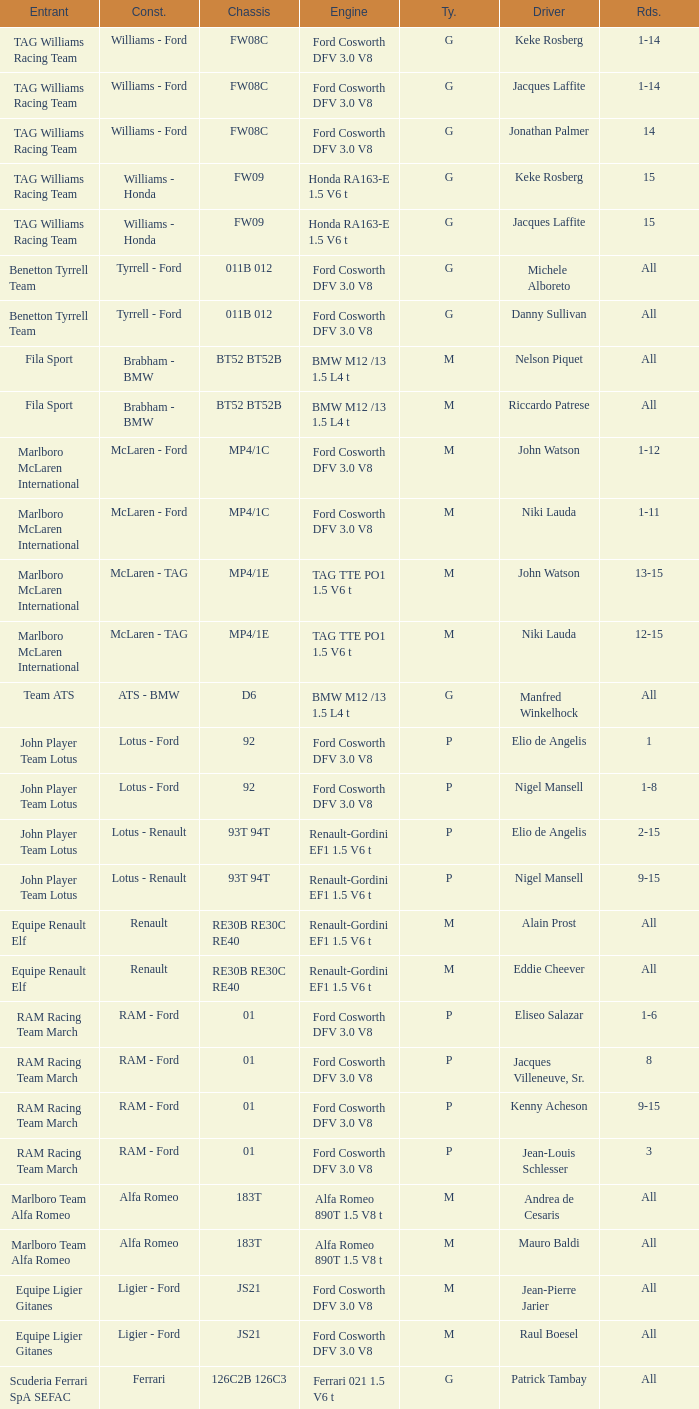Who is the Constructor for driver Piercarlo Ghinzani and a Ford cosworth dfv 3.0 v8 engine? Osella - Ford. 